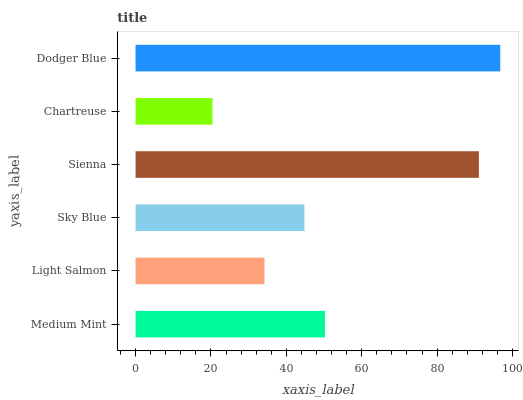Is Chartreuse the minimum?
Answer yes or no. Yes. Is Dodger Blue the maximum?
Answer yes or no. Yes. Is Light Salmon the minimum?
Answer yes or no. No. Is Light Salmon the maximum?
Answer yes or no. No. Is Medium Mint greater than Light Salmon?
Answer yes or no. Yes. Is Light Salmon less than Medium Mint?
Answer yes or no. Yes. Is Light Salmon greater than Medium Mint?
Answer yes or no. No. Is Medium Mint less than Light Salmon?
Answer yes or no. No. Is Medium Mint the high median?
Answer yes or no. Yes. Is Sky Blue the low median?
Answer yes or no. Yes. Is Sienna the high median?
Answer yes or no. No. Is Light Salmon the low median?
Answer yes or no. No. 